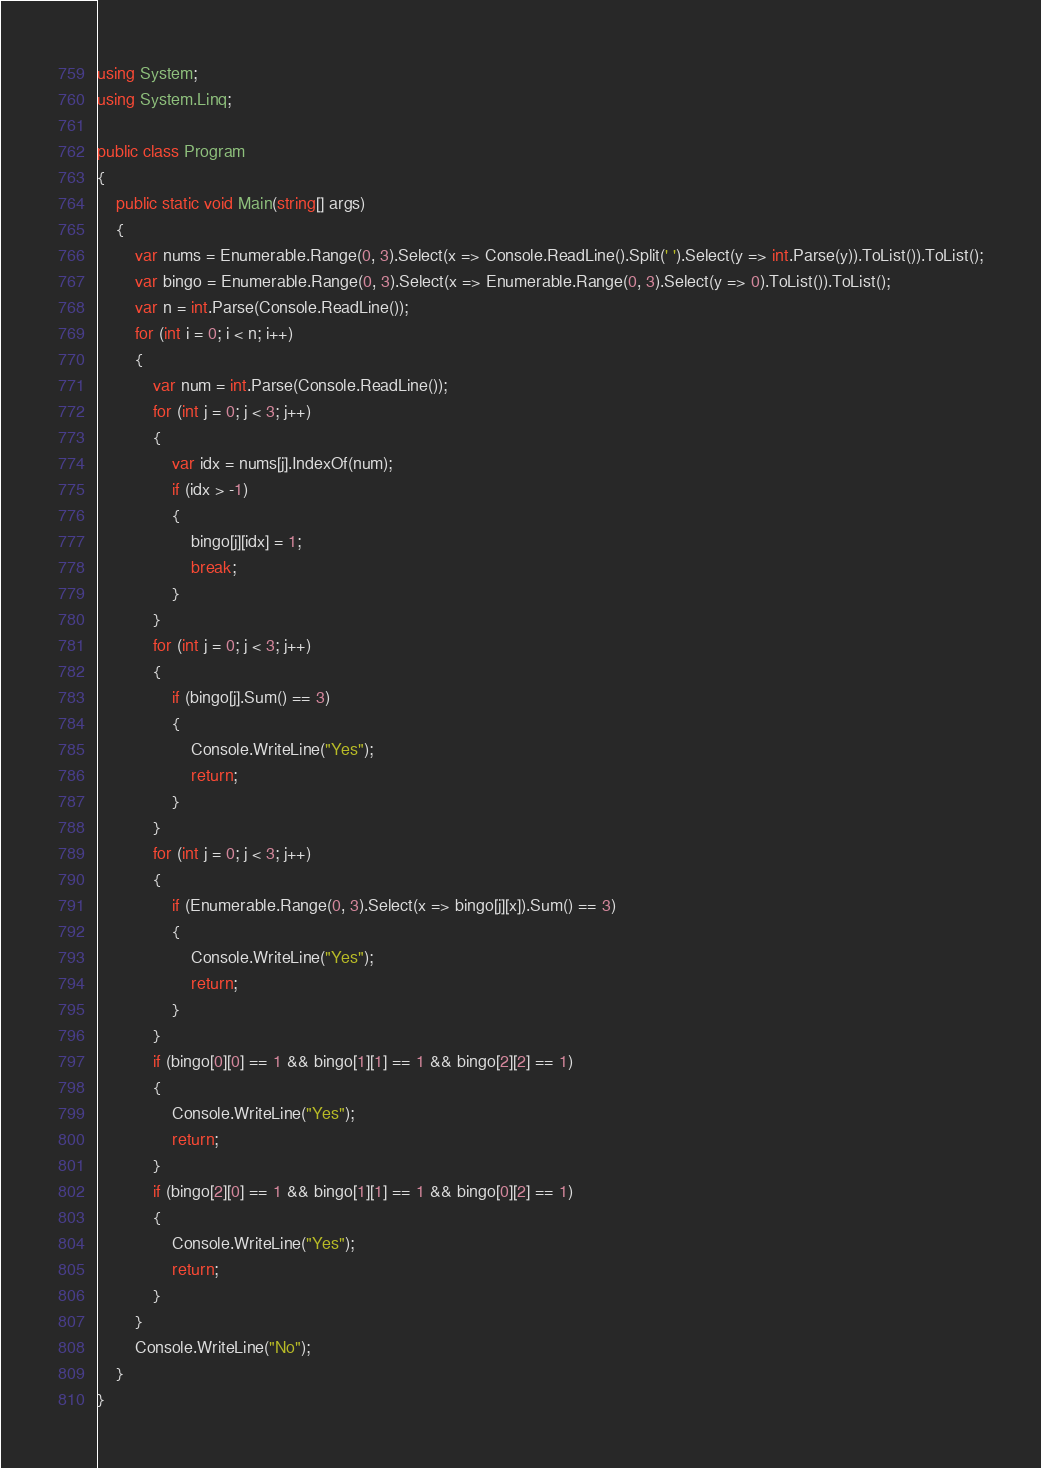<code> <loc_0><loc_0><loc_500><loc_500><_C#_>using System;
using System.Linq;

public class Program
{
    public static void Main(string[] args)
    {
        var nums = Enumerable.Range(0, 3).Select(x => Console.ReadLine().Split(' ').Select(y => int.Parse(y)).ToList()).ToList();
        var bingo = Enumerable.Range(0, 3).Select(x => Enumerable.Range(0, 3).Select(y => 0).ToList()).ToList();
        var n = int.Parse(Console.ReadLine());
        for (int i = 0; i < n; i++)
        {
            var num = int.Parse(Console.ReadLine());
            for (int j = 0; j < 3; j++)
            {
                var idx = nums[j].IndexOf(num);
                if (idx > -1)
                {
                    bingo[j][idx] = 1;
                    break;
                }
            }
            for (int j = 0; j < 3; j++)
            {
                if (bingo[j].Sum() == 3)
                {
                    Console.WriteLine("Yes");
                    return;
                }
            }
            for (int j = 0; j < 3; j++)
            {
                if (Enumerable.Range(0, 3).Select(x => bingo[j][x]).Sum() == 3)
                {
                    Console.WriteLine("Yes");
                    return;
                }
            }
            if (bingo[0][0] == 1 && bingo[1][1] == 1 && bingo[2][2] == 1)
            {
                Console.WriteLine("Yes");
                return;
            }
            if (bingo[2][0] == 1 && bingo[1][1] == 1 && bingo[0][2] == 1)
            {
                Console.WriteLine("Yes");
                return;
            }
        }
        Console.WriteLine("No");
    }
}</code> 